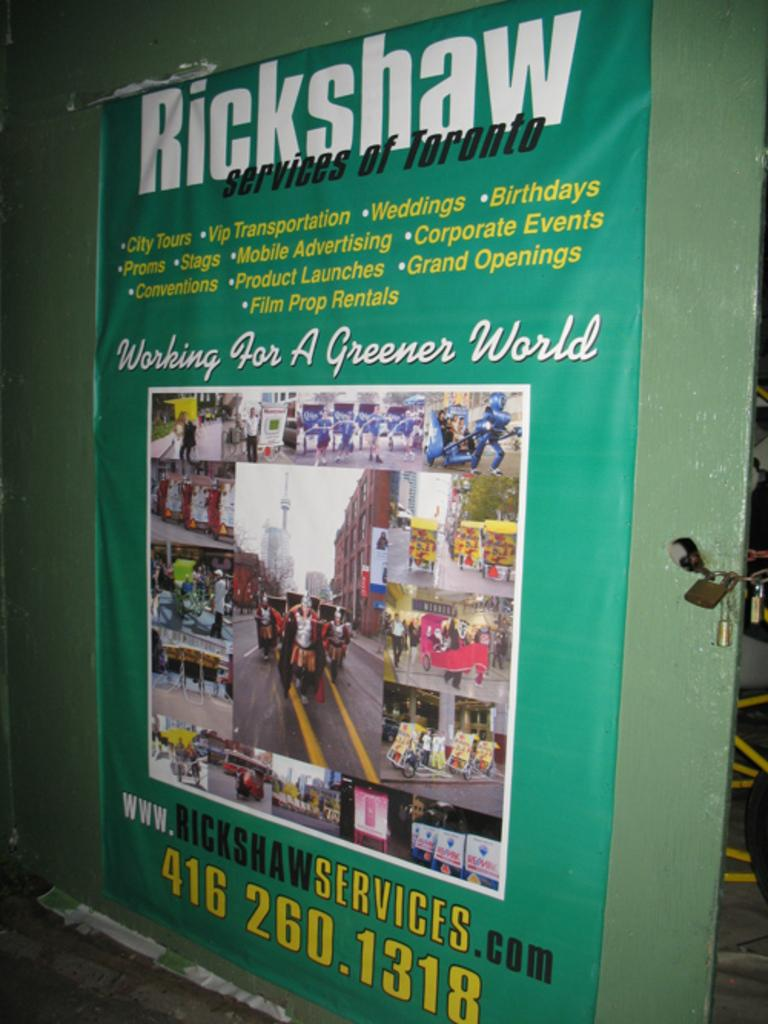What is hanging in the image? There is a banner in the image. What is displayed on the banner? The banner contains photos, words, and numbers. How is the banner supported or attached? The banner is attached to a board. Are there any additional objects visible on the right side of the image? Yes, there are three padlocks on the right side of the image. What invention is being rewarded in the image? There is no invention or reward mentioned or depicted in the image. 